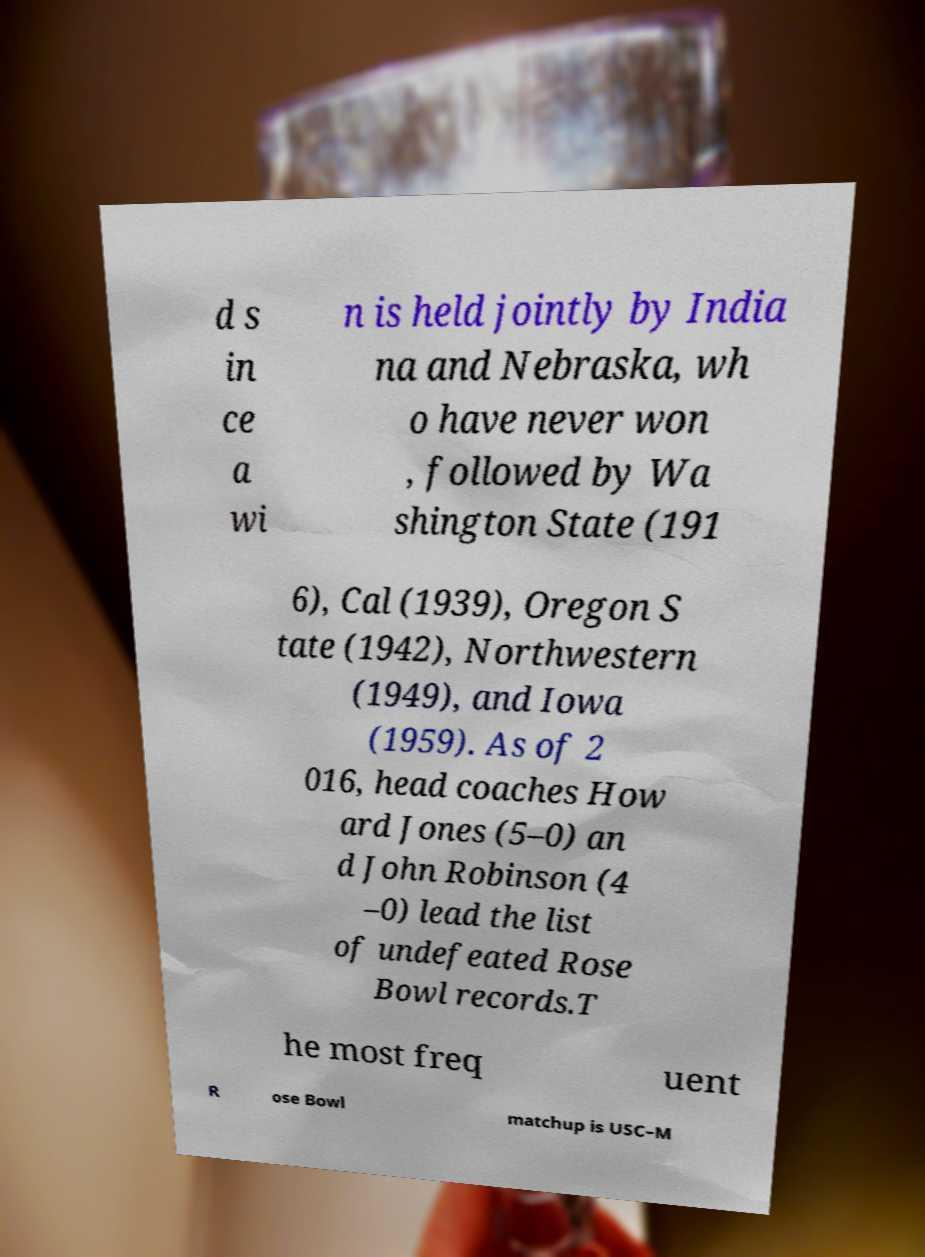Could you assist in decoding the text presented in this image and type it out clearly? d s in ce a wi n is held jointly by India na and Nebraska, wh o have never won , followed by Wa shington State (191 6), Cal (1939), Oregon S tate (1942), Northwestern (1949), and Iowa (1959). As of 2 016, head coaches How ard Jones (5–0) an d John Robinson (4 –0) lead the list of undefeated Rose Bowl records.T he most freq uent R ose Bowl matchup is USC–M 